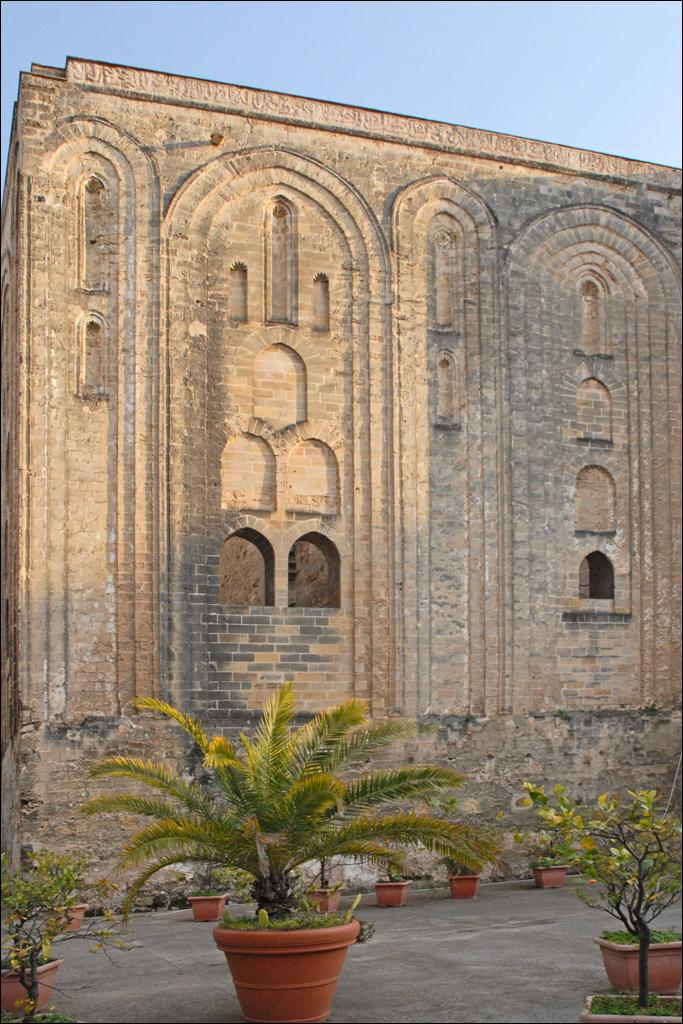What type of objects are placed on the floor at the bottom of the image? There are potted plants on the floor at the bottom of the image. What can be seen behind the potted plants? There is a wall with arches behind the potted plants. What is visible at the top of the image? The sky is visible at the top of the image. What type of country is depicted in the image? There is no country depicted in the image; it features potted plants, a wall with arches, and the sky. How does the animal grip the wall in the image? There is no animal present in the image, so it is not possible to determine how an animal might grip the wall. 